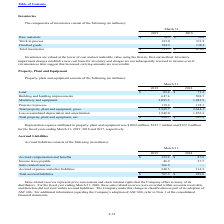According to Microchip Technology's financial document, How were inventories valued at the lower of cost and net realizable value? using the first-in, first-out method.. The document states: "lued at the lower of cost and net realizable value using the first-in, first-out method. Inventory..." Also, Which years does the table provide information for the components of inventories? The document shows two values: 2019 and 2018. From the document: "2019 2018 2019 2018..." Also, What was the amount of raw materials in 2018? According to the financial document, 26.0 (in millions). The relevant text states: "Raw materials $ 74.5 $ 26.0..." Also, can you calculate: What was the change in raw materials between 2018 and 2019? Based on the calculation: 74.5-26.0, the result is 48.5 (in millions). This is based on the information: "Raw materials $ 74.5 $ 26.0 Raw materials $ 74.5 $ 26.0..." The key data points involved are: 26.0, 74.5. Also, How many years did the amount of Finished goods exceed $200 million? Based on the analysis, there are 1 instances. The counting process: 2019. Also, can you calculate: What was the percentage change in total inventories between 2018 and 2019? To answer this question, I need to perform calculations using the financial data. The calculation is: (711.7-476.2)/476.2, which equals 49.45 (percentage). This is based on the information: "Total inventories $ 711.7 $ 476.2 Total inventories $ 711.7 $ 476.2..." The key data points involved are: 476.2, 711.7. 